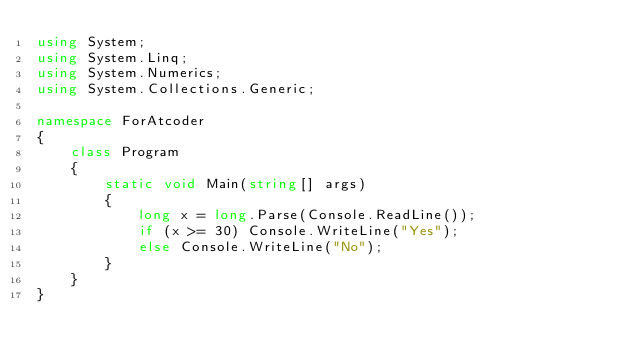Convert code to text. <code><loc_0><loc_0><loc_500><loc_500><_C#_>using System;
using System.Linq;
using System.Numerics;
using System.Collections.Generic;

namespace ForAtcoder
{
    class Program
    {
        static void Main(string[] args)
        {
            long x = long.Parse(Console.ReadLine());
            if (x >= 30) Console.WriteLine("Yes");
            else Console.WriteLine("No");
        }
    }
}</code> 